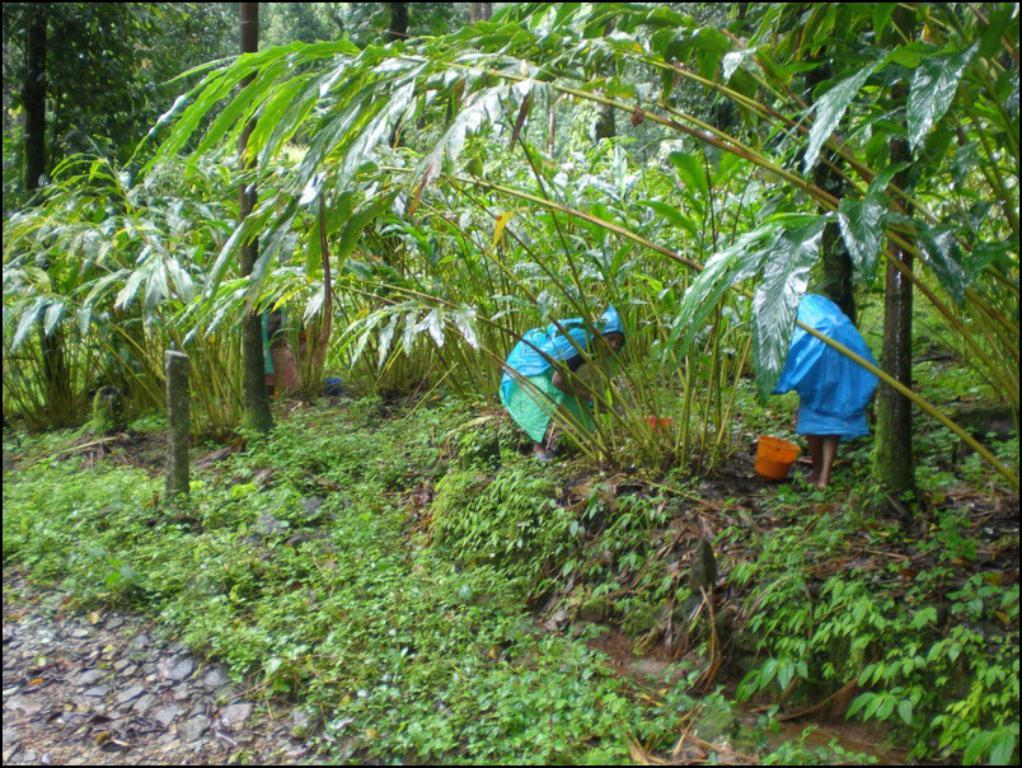How many people are present in the image? There are two people in the image. What object can be seen besides the people? There is a bucket in the image. What type of vegetation is visible in the background of the image? There are trees in the background of the image. What type of ground surface is visible at the bottom of the image? There is grass visible at the bottom of the image. What type of feather can be seen on the cap of one of the people in the image? There is no cap or feather present on any of the people in the image. Can you describe the goose that is walking through the grass in the image? There is no goose present in the image; it only features two people, a bucket, trees, and grass. 